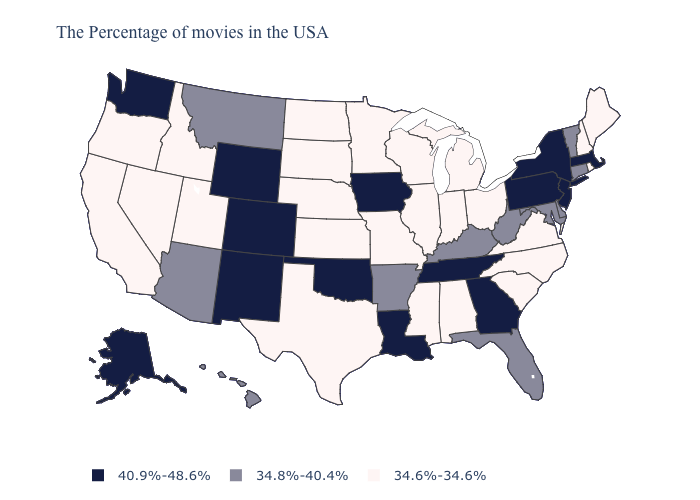Does Kentucky have the lowest value in the USA?
Be succinct. No. What is the lowest value in the USA?
Write a very short answer. 34.6%-34.6%. Name the states that have a value in the range 34.6%-34.6%?
Give a very brief answer. Maine, Rhode Island, New Hampshire, Virginia, North Carolina, South Carolina, Ohio, Michigan, Indiana, Alabama, Wisconsin, Illinois, Mississippi, Missouri, Minnesota, Kansas, Nebraska, Texas, South Dakota, North Dakota, Utah, Idaho, Nevada, California, Oregon. Among the states that border Kansas , does Nebraska have the lowest value?
Concise answer only. Yes. Name the states that have a value in the range 34.8%-40.4%?
Give a very brief answer. Vermont, Connecticut, Delaware, Maryland, West Virginia, Florida, Kentucky, Arkansas, Montana, Arizona, Hawaii. Name the states that have a value in the range 34.6%-34.6%?
Keep it brief. Maine, Rhode Island, New Hampshire, Virginia, North Carolina, South Carolina, Ohio, Michigan, Indiana, Alabama, Wisconsin, Illinois, Mississippi, Missouri, Minnesota, Kansas, Nebraska, Texas, South Dakota, North Dakota, Utah, Idaho, Nevada, California, Oregon. What is the highest value in states that border Utah?
Keep it brief. 40.9%-48.6%. Among the states that border Missouri , which have the highest value?
Be succinct. Tennessee, Iowa, Oklahoma. Name the states that have a value in the range 40.9%-48.6%?
Answer briefly. Massachusetts, New York, New Jersey, Pennsylvania, Georgia, Tennessee, Louisiana, Iowa, Oklahoma, Wyoming, Colorado, New Mexico, Washington, Alaska. Does Hawaii have the lowest value in the West?
Concise answer only. No. Name the states that have a value in the range 34.8%-40.4%?
Concise answer only. Vermont, Connecticut, Delaware, Maryland, West Virginia, Florida, Kentucky, Arkansas, Montana, Arizona, Hawaii. Does the first symbol in the legend represent the smallest category?
Give a very brief answer. No. Name the states that have a value in the range 34.8%-40.4%?
Quick response, please. Vermont, Connecticut, Delaware, Maryland, West Virginia, Florida, Kentucky, Arkansas, Montana, Arizona, Hawaii. What is the value of Colorado?
Concise answer only. 40.9%-48.6%. What is the value of Montana?
Concise answer only. 34.8%-40.4%. 